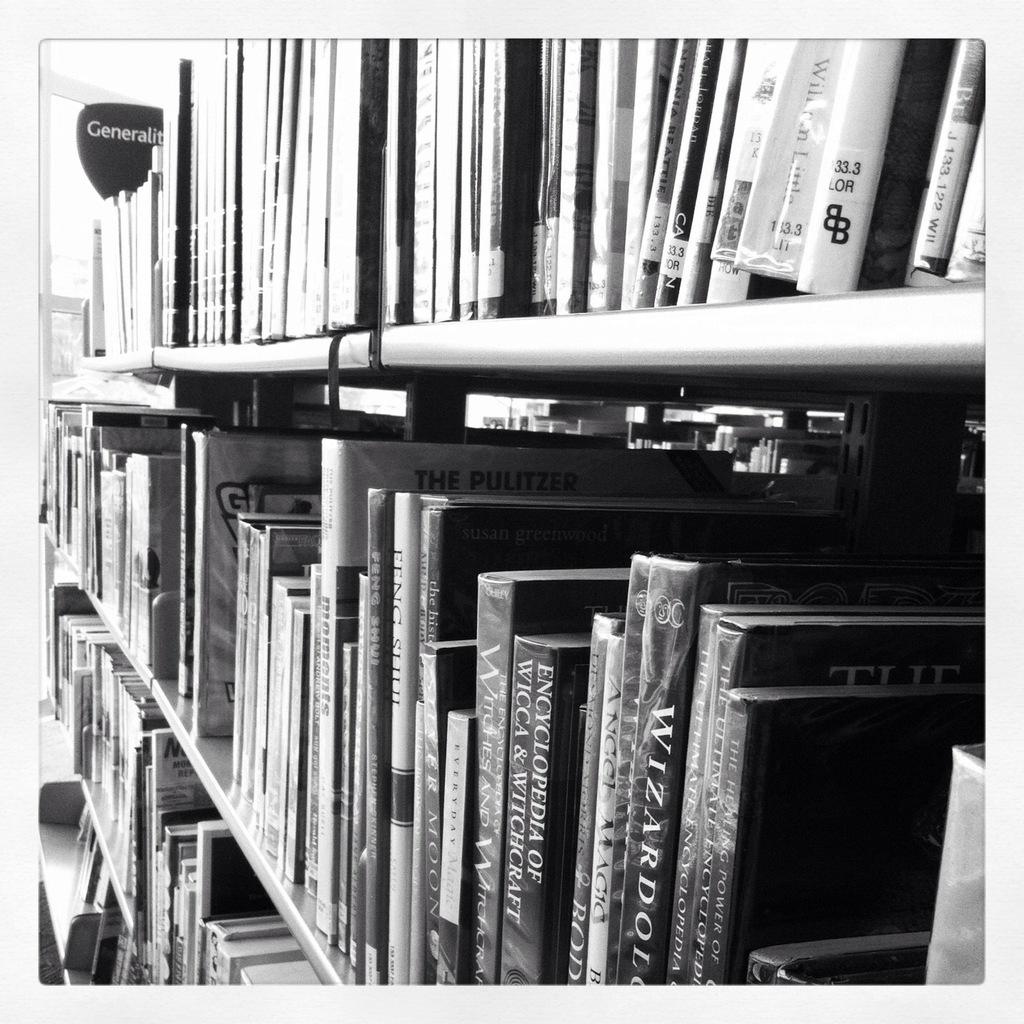<image>
Describe the image concisely. Book shelf that has a book titled "The Pulitzer". 